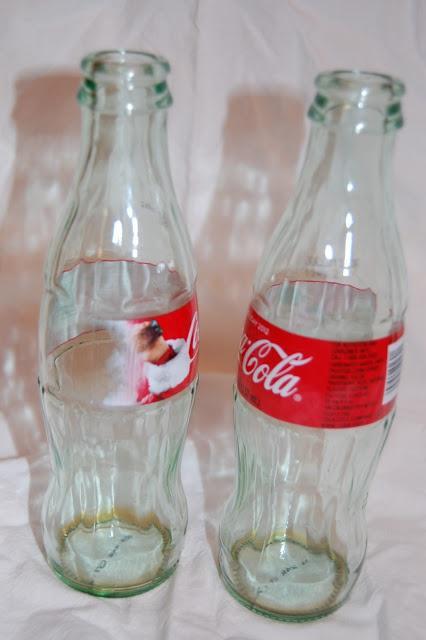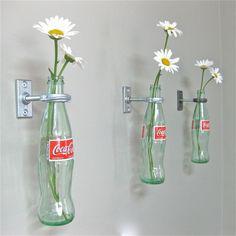The first image is the image on the left, the second image is the image on the right. Given the left and right images, does the statement "There is no more than three bottles in the right image." hold true? Answer yes or no. Yes. 